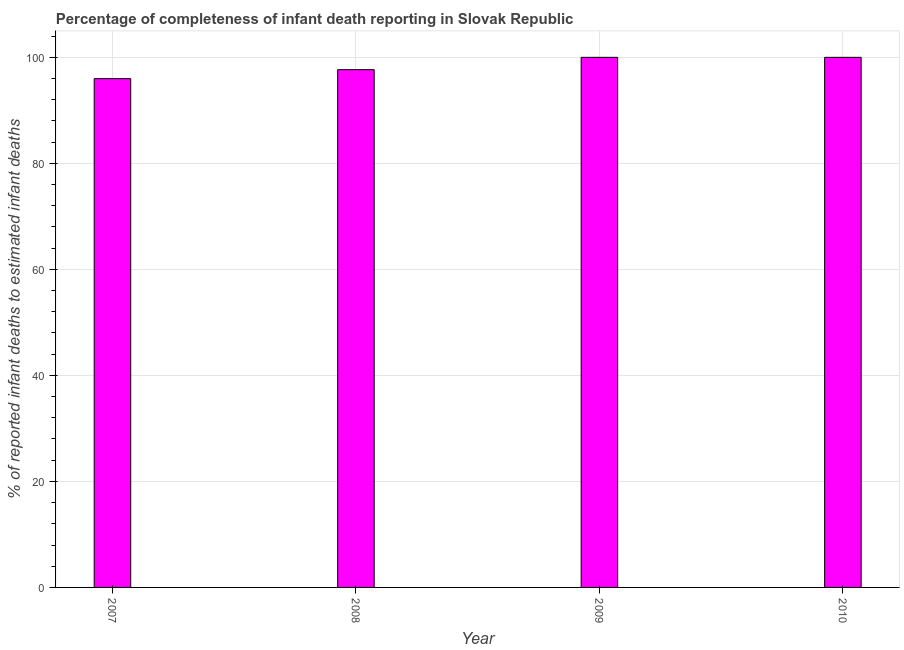What is the title of the graph?
Offer a very short reply. Percentage of completeness of infant death reporting in Slovak Republic. What is the label or title of the X-axis?
Ensure brevity in your answer.  Year. What is the label or title of the Y-axis?
Ensure brevity in your answer.  % of reported infant deaths to estimated infant deaths. What is the completeness of infant death reporting in 2010?
Your response must be concise. 100. Across all years, what is the maximum completeness of infant death reporting?
Give a very brief answer. 100. Across all years, what is the minimum completeness of infant death reporting?
Provide a succinct answer. 95.98. What is the sum of the completeness of infant death reporting?
Offer a very short reply. 393.65. What is the difference between the completeness of infant death reporting in 2007 and 2009?
Make the answer very short. -4.02. What is the average completeness of infant death reporting per year?
Ensure brevity in your answer.  98.41. What is the median completeness of infant death reporting?
Keep it short and to the point. 98.84. In how many years, is the completeness of infant death reporting greater than 92 %?
Give a very brief answer. 4. Do a majority of the years between 2008 and 2009 (inclusive) have completeness of infant death reporting greater than 64 %?
Provide a succinct answer. Yes. Is the completeness of infant death reporting in 2009 less than that in 2010?
Give a very brief answer. No. Is the difference between the completeness of infant death reporting in 2008 and 2009 greater than the difference between any two years?
Offer a very short reply. No. What is the difference between the highest and the second highest completeness of infant death reporting?
Make the answer very short. 0. What is the difference between the highest and the lowest completeness of infant death reporting?
Offer a terse response. 4.02. How many years are there in the graph?
Offer a very short reply. 4. What is the % of reported infant deaths to estimated infant deaths in 2007?
Provide a succinct answer. 95.98. What is the % of reported infant deaths to estimated infant deaths of 2008?
Provide a short and direct response. 97.67. What is the % of reported infant deaths to estimated infant deaths in 2009?
Your answer should be compact. 100. What is the difference between the % of reported infant deaths to estimated infant deaths in 2007 and 2008?
Provide a short and direct response. -1.7. What is the difference between the % of reported infant deaths to estimated infant deaths in 2007 and 2009?
Offer a terse response. -4.02. What is the difference between the % of reported infant deaths to estimated infant deaths in 2007 and 2010?
Ensure brevity in your answer.  -4.02. What is the difference between the % of reported infant deaths to estimated infant deaths in 2008 and 2009?
Provide a succinct answer. -2.33. What is the difference between the % of reported infant deaths to estimated infant deaths in 2008 and 2010?
Provide a short and direct response. -2.33. What is the ratio of the % of reported infant deaths to estimated infant deaths in 2007 to that in 2008?
Offer a terse response. 0.98. What is the ratio of the % of reported infant deaths to estimated infant deaths in 2007 to that in 2010?
Offer a terse response. 0.96. What is the ratio of the % of reported infant deaths to estimated infant deaths in 2008 to that in 2010?
Provide a short and direct response. 0.98. 